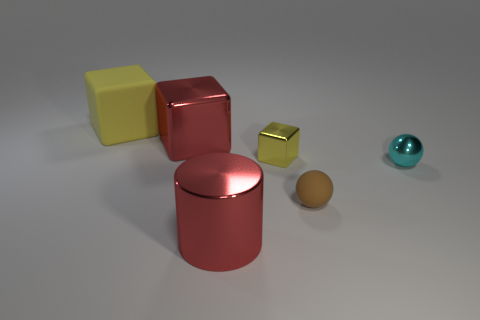What number of other objects are there of the same material as the tiny yellow block?
Your answer should be very brief. 3. What number of things are large purple metallic cubes or shiny things that are in front of the tiny cyan ball?
Your response must be concise. 1. Are there fewer tiny brown spheres than red metallic things?
Provide a succinct answer. Yes. The matte object in front of the yellow cube that is on the left side of the red metal thing that is in front of the matte ball is what color?
Ensure brevity in your answer.  Brown. Do the cyan thing and the red cylinder have the same material?
Offer a very short reply. Yes. What number of tiny cyan shiny spheres are in front of the large red metallic cylinder?
Give a very brief answer. 0. The red metal thing that is the same shape as the large yellow object is what size?
Offer a terse response. Large. How many red things are rubber blocks or metal cylinders?
Your answer should be very brief. 1. There is a yellow metal object that is behind the small cyan object; how many big things are behind it?
Offer a terse response. 2. How many other objects are there of the same shape as the small yellow metal thing?
Offer a very short reply. 2. 